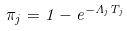<formula> <loc_0><loc_0><loc_500><loc_500>\pi _ { j } = 1 - e ^ { - \Lambda _ { j } T _ { j } }</formula> 